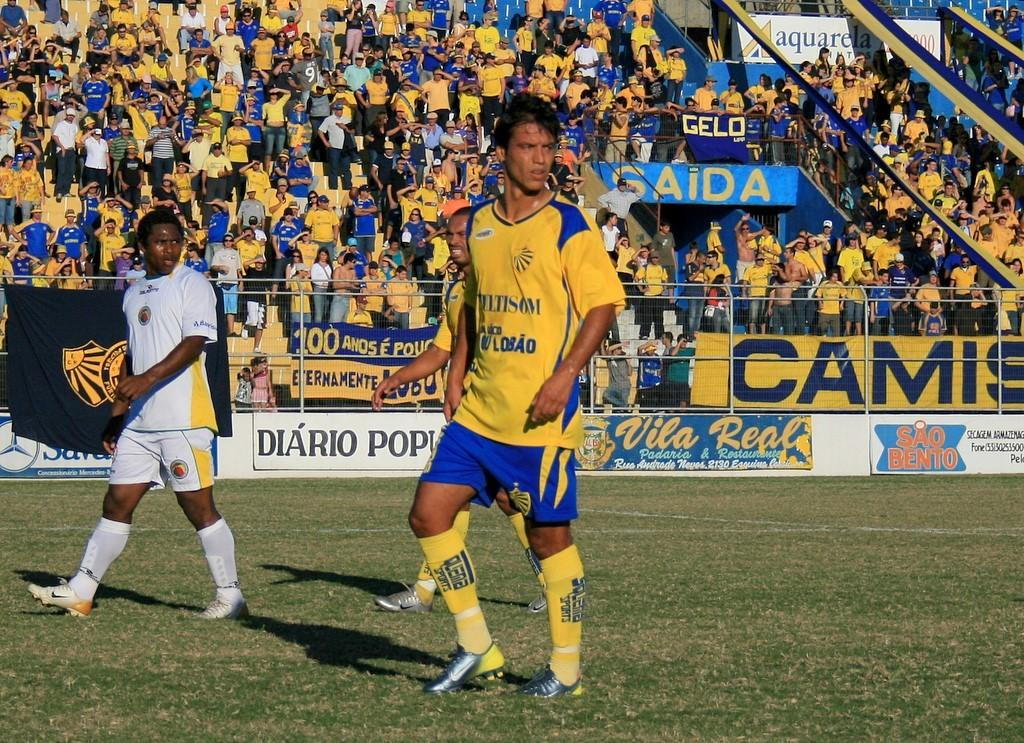Provide a one-sentence caption for the provided image. Sao Bento advertising on the wall at a soccer match. 